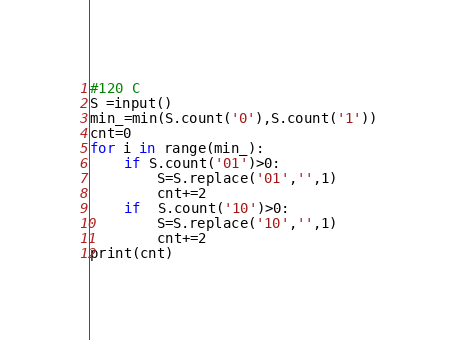Convert code to text. <code><loc_0><loc_0><loc_500><loc_500><_Python_>#120 C
S =input()
min_=min(S.count('0'),S.count('1'))
cnt=0
for i in range(min_):
    if S.count('01')>0:
        S=S.replace('01','',1)
        cnt+=2
    if  S.count('10')>0:
        S=S.replace('10','',1)
        cnt+=2
print(cnt)</code> 